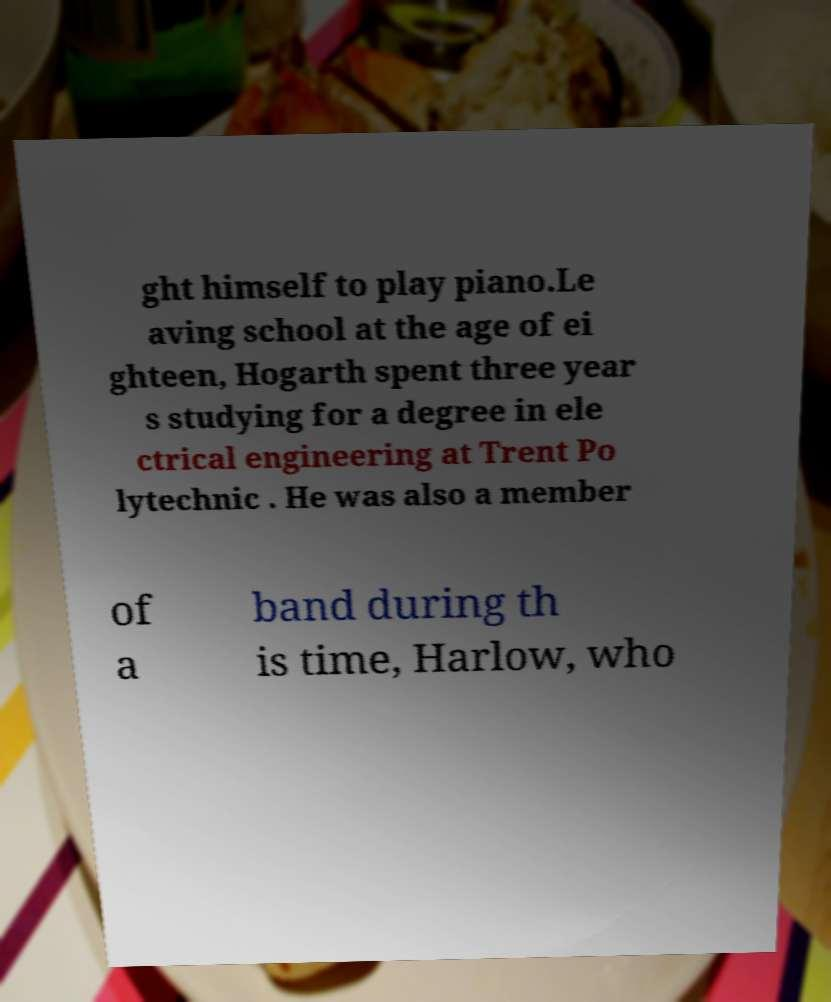What messages or text are displayed in this image? I need them in a readable, typed format. ght himself to play piano.Le aving school at the age of ei ghteen, Hogarth spent three year s studying for a degree in ele ctrical engineering at Trent Po lytechnic . He was also a member of a band during th is time, Harlow, who 